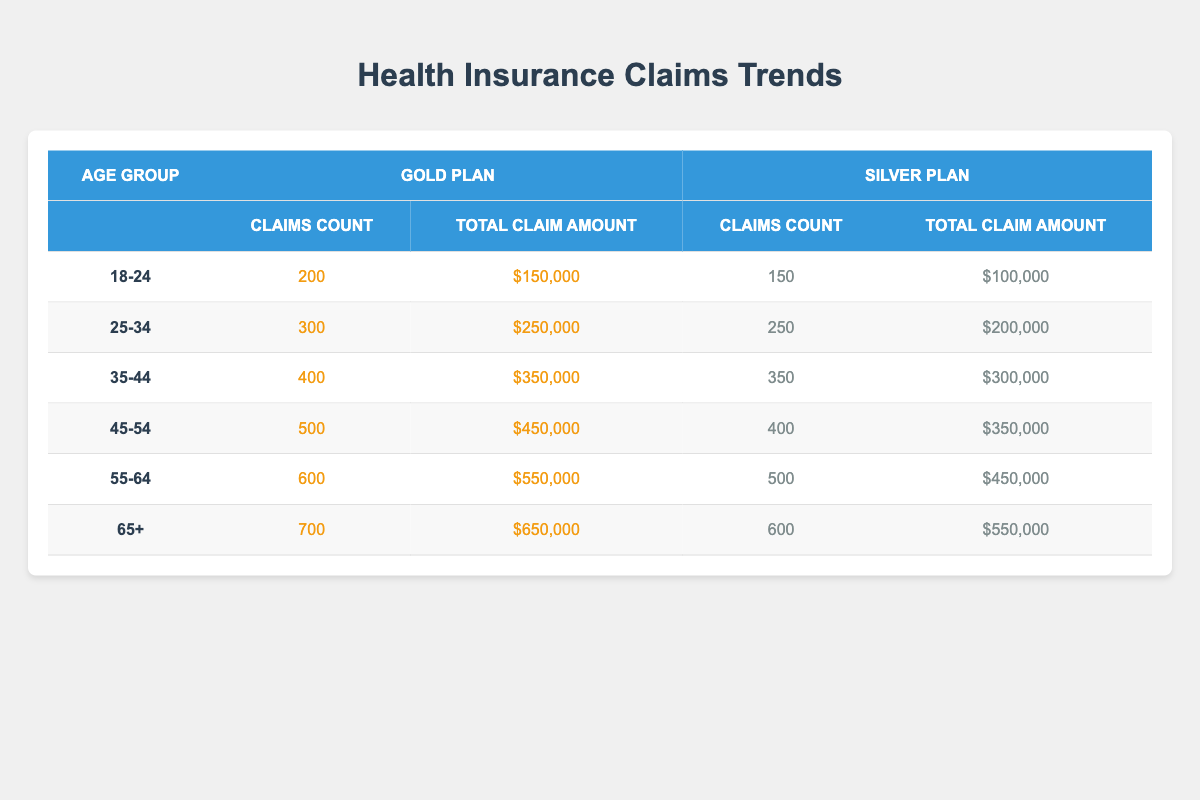What is the claims count for the Silver plan in the 45-54 age group? In the table, locate the row for the age group 45-54 and the column for the Silver plan. The claims count in this row and column is 400.
Answer: 400 Which age group has the highest total claim amount for the Gold plan? Looking at the Gold plan columns, compare the total claim amounts for each age group: 150000 (18-24), 250000 (25-34), 350000 (35-44), 450000 (45-54), 550000 (55-64), and 650000 (65+). The highest value is 650000 for the age group 65+.
Answer: 65+ What is the total number of claims for all age groups combined in the Silver plan? To find the total claims for the Silver plan, add the claims counts from each age group: 150 (18-24) + 250 (25-34) + 350 (35-44) + 400 (45-54) + 500 (55-64) + 600 (65+) = 2250.
Answer: 2250 Does the Gold plan have more claims than the Silver plan in the 35-44 age group? In the 35-44 age group, the Gold plan has 400 claims and the Silver plan has 350 claims. Since 400 is greater than 350, the Gold plan has more claims.
Answer: Yes What is the average total claim amount for the Silver plan across all age groups? For the Silver plan, the total claim amounts are: 100000 (18-24) + 200000 (25-34) + 300000 (35-44) + 350000 (45-54) + 450000 (55-64) + 550000 (65+). The total is 1950000 and there are 6 age groups, so the average is 1950000/6 = 325000.
Answer: 325000 What is the difference in claims count between the Gold and Silver plans for the 55-64 age group? For the 55-64 age group, the Gold plan has 600 claims and the Silver plan has 500 claims. The difference is 600 - 500 = 100.
Answer: 100 Which age group has the lowest total claim amount for the Gold plan? Check the total claim amounts for the Gold plan: 150000 (18-24), 250000 (25-34), 350000 (35-44), 450000 (45-54), 550000 (55-64), and 650000 (65+). The lowest amount is 150000 for the age group 18-24.
Answer: 18-24 